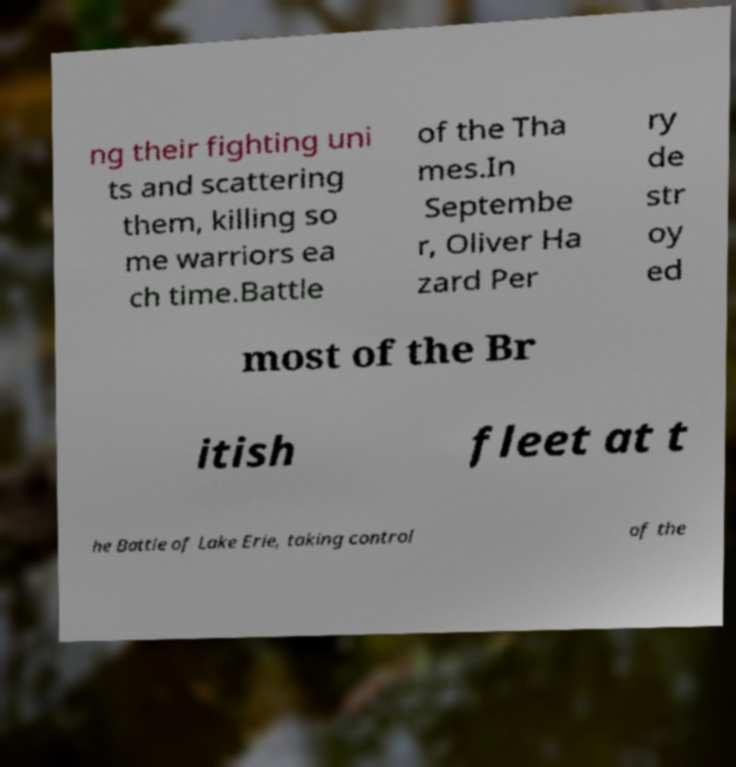I need the written content from this picture converted into text. Can you do that? ng their fighting uni ts and scattering them, killing so me warriors ea ch time.Battle of the Tha mes.In Septembe r, Oliver Ha zard Per ry de str oy ed most of the Br itish fleet at t he Battle of Lake Erie, taking control of the 